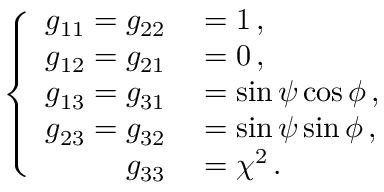<formula> <loc_0><loc_0><loc_500><loc_500>\left \{ \begin{array} { r l } { g _ { 1 1 } = g _ { 2 2 } } & = 1 \, , } \\ { g _ { 1 2 } = g _ { 2 1 } } & = 0 \, , } \\ { g _ { 1 3 } = g _ { 3 1 } } & = \sin \psi \cos \phi \, , } \\ { g _ { 2 3 } = g _ { 3 2 } } & = \sin \psi \sin \phi \, , } \\ { g _ { 3 3 } } & = \chi ^ { 2 } \, . } \end{array}</formula> 